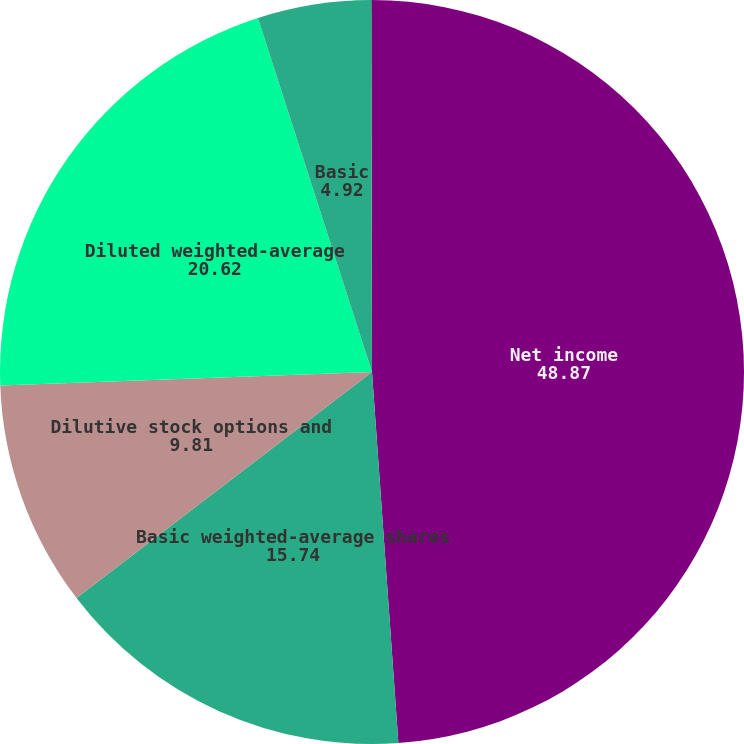Convert chart. <chart><loc_0><loc_0><loc_500><loc_500><pie_chart><fcel>Net income<fcel>Basic weighted-average shares<fcel>Dilutive stock options and<fcel>Diluted weighted-average<fcel>Basic<fcel>Diluted<nl><fcel>48.87%<fcel>15.74%<fcel>9.81%<fcel>20.62%<fcel>4.92%<fcel>0.04%<nl></chart> 